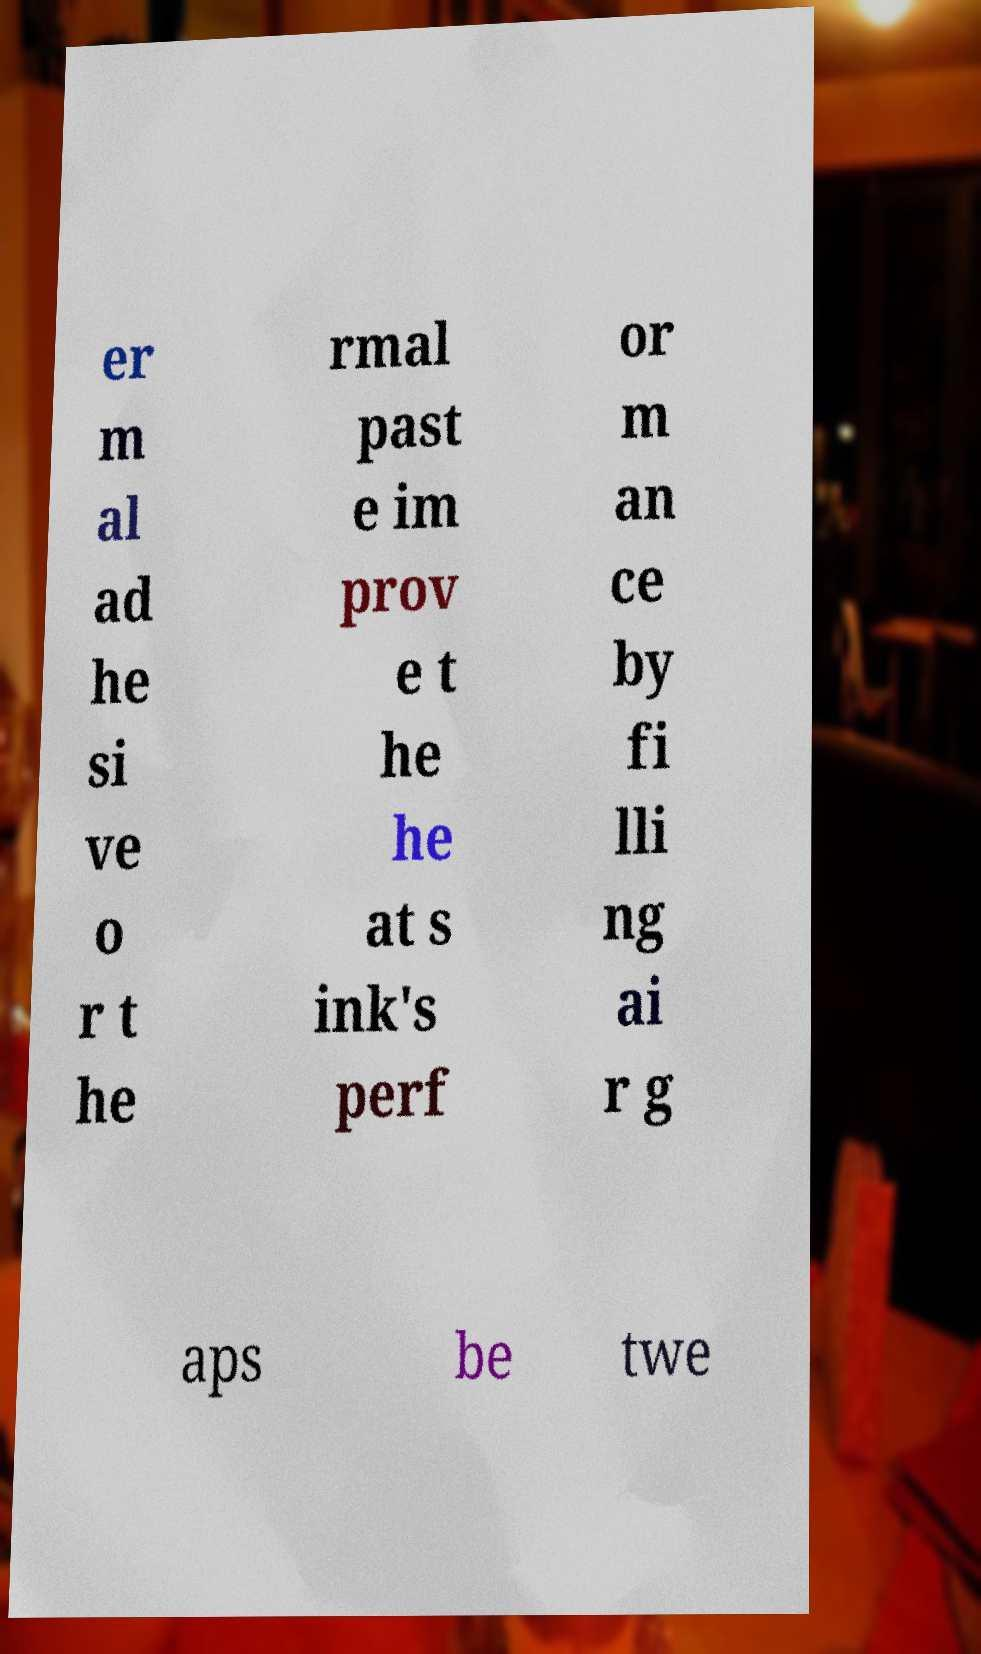Could you extract and type out the text from this image? er m al ad he si ve o r t he rmal past e im prov e t he he at s ink's perf or m an ce by fi lli ng ai r g aps be twe 